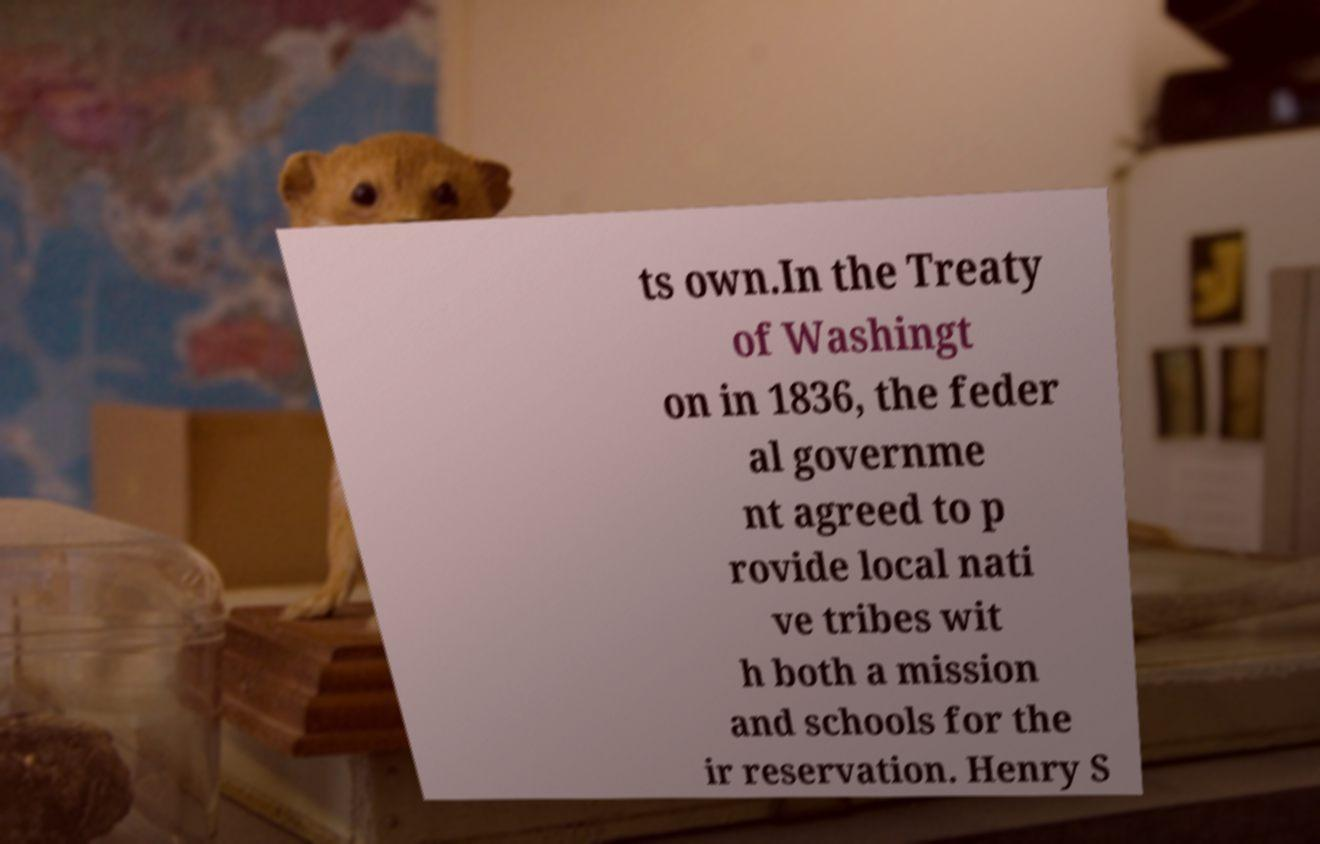Please read and relay the text visible in this image. What does it say? ts own.In the Treaty of Washingt on in 1836, the feder al governme nt agreed to p rovide local nati ve tribes wit h both a mission and schools for the ir reservation. Henry S 